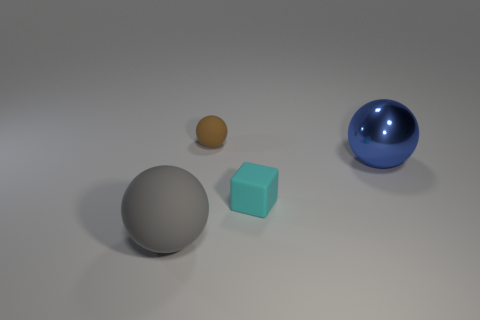Is there any other thing that is the same material as the blue thing?
Offer a terse response. No. What number of objects are rubber objects that are in front of the large metal ball or blue shiny spheres?
Provide a succinct answer. 3. There is a brown object that is the same material as the cyan cube; what shape is it?
Offer a terse response. Sphere. How many large matte objects are the same shape as the blue metallic thing?
Your response must be concise. 1. What is the material of the tiny brown sphere?
Your answer should be very brief. Rubber. Do the tiny matte ball and the big ball that is behind the large gray matte object have the same color?
Provide a short and direct response. No. What number of cylinders are big metal things or cyan rubber things?
Give a very brief answer. 0. What color is the rubber thing that is in front of the cyan matte thing?
Offer a very short reply. Gray. What number of blue blocks have the same size as the gray object?
Provide a succinct answer. 0. There is a small matte object left of the small cyan object; does it have the same shape as the big object that is behind the big gray thing?
Offer a terse response. Yes. 